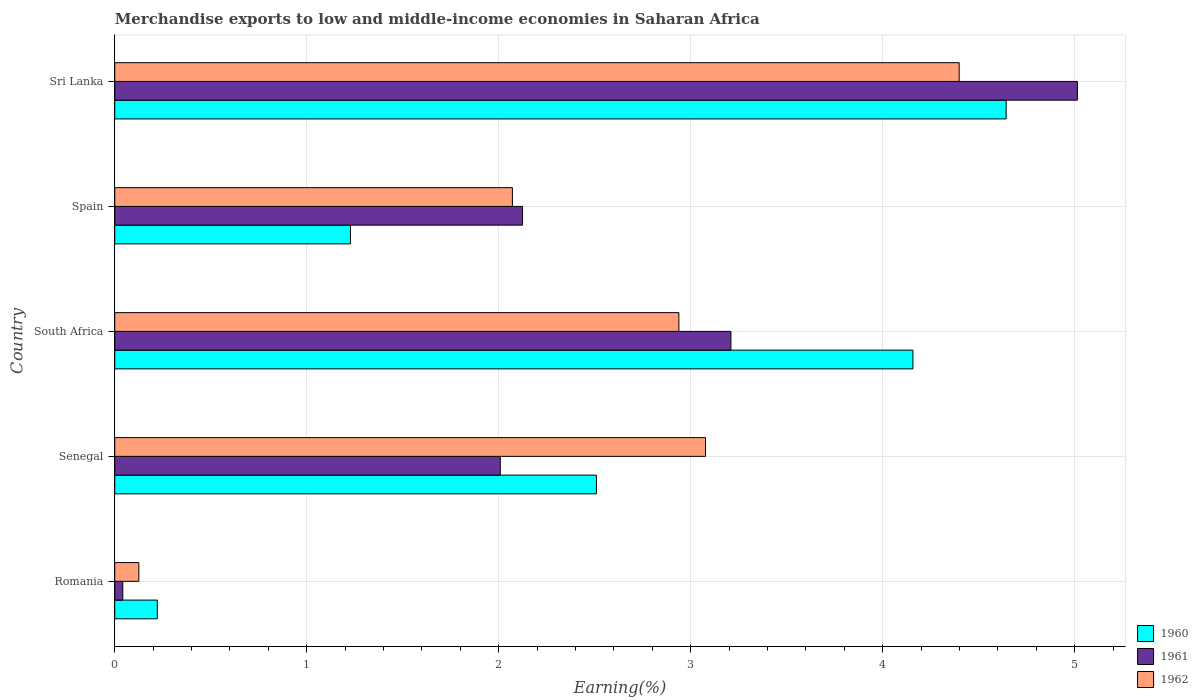How many different coloured bars are there?
Your answer should be compact. 3. How many groups of bars are there?
Make the answer very short. 5. Are the number of bars per tick equal to the number of legend labels?
Provide a short and direct response. Yes. How many bars are there on the 5th tick from the bottom?
Make the answer very short. 3. What is the label of the 3rd group of bars from the top?
Offer a very short reply. South Africa. What is the percentage of amount earned from merchandise exports in 1960 in South Africa?
Keep it short and to the point. 4.16. Across all countries, what is the maximum percentage of amount earned from merchandise exports in 1962?
Your response must be concise. 4.4. Across all countries, what is the minimum percentage of amount earned from merchandise exports in 1960?
Make the answer very short. 0.22. In which country was the percentage of amount earned from merchandise exports in 1960 maximum?
Ensure brevity in your answer.  Sri Lanka. In which country was the percentage of amount earned from merchandise exports in 1962 minimum?
Provide a succinct answer. Romania. What is the total percentage of amount earned from merchandise exports in 1962 in the graph?
Offer a very short reply. 12.61. What is the difference between the percentage of amount earned from merchandise exports in 1962 in Romania and that in Spain?
Your answer should be very brief. -1.95. What is the difference between the percentage of amount earned from merchandise exports in 1961 in Sri Lanka and the percentage of amount earned from merchandise exports in 1960 in South Africa?
Your response must be concise. 0.86. What is the average percentage of amount earned from merchandise exports in 1960 per country?
Ensure brevity in your answer.  2.55. What is the difference between the percentage of amount earned from merchandise exports in 1961 and percentage of amount earned from merchandise exports in 1962 in Romania?
Your response must be concise. -0.08. What is the ratio of the percentage of amount earned from merchandise exports in 1961 in Senegal to that in Sri Lanka?
Make the answer very short. 0.4. Is the percentage of amount earned from merchandise exports in 1962 in Senegal less than that in Sri Lanka?
Provide a short and direct response. Yes. What is the difference between the highest and the second highest percentage of amount earned from merchandise exports in 1960?
Ensure brevity in your answer.  0.49. What is the difference between the highest and the lowest percentage of amount earned from merchandise exports in 1960?
Your answer should be compact. 4.42. Is the sum of the percentage of amount earned from merchandise exports in 1961 in Romania and Sri Lanka greater than the maximum percentage of amount earned from merchandise exports in 1960 across all countries?
Make the answer very short. Yes. Is it the case that in every country, the sum of the percentage of amount earned from merchandise exports in 1961 and percentage of amount earned from merchandise exports in 1962 is greater than the percentage of amount earned from merchandise exports in 1960?
Give a very brief answer. No. How many bars are there?
Provide a succinct answer. 15. Are all the bars in the graph horizontal?
Your answer should be compact. Yes. What is the difference between two consecutive major ticks on the X-axis?
Provide a short and direct response. 1. Are the values on the major ticks of X-axis written in scientific E-notation?
Give a very brief answer. No. Does the graph contain grids?
Offer a terse response. Yes. What is the title of the graph?
Offer a very short reply. Merchandise exports to low and middle-income economies in Saharan Africa. What is the label or title of the X-axis?
Your answer should be compact. Earning(%). What is the Earning(%) in 1960 in Romania?
Offer a very short reply. 0.22. What is the Earning(%) of 1961 in Romania?
Ensure brevity in your answer.  0.04. What is the Earning(%) of 1962 in Romania?
Make the answer very short. 0.13. What is the Earning(%) in 1960 in Senegal?
Offer a terse response. 2.51. What is the Earning(%) of 1961 in Senegal?
Give a very brief answer. 2.01. What is the Earning(%) in 1962 in Senegal?
Provide a short and direct response. 3.08. What is the Earning(%) of 1960 in South Africa?
Keep it short and to the point. 4.16. What is the Earning(%) of 1961 in South Africa?
Offer a terse response. 3.21. What is the Earning(%) of 1962 in South Africa?
Provide a short and direct response. 2.94. What is the Earning(%) of 1960 in Spain?
Provide a succinct answer. 1.23. What is the Earning(%) of 1961 in Spain?
Give a very brief answer. 2.12. What is the Earning(%) in 1962 in Spain?
Keep it short and to the point. 2.07. What is the Earning(%) of 1960 in Sri Lanka?
Your answer should be very brief. 4.64. What is the Earning(%) of 1961 in Sri Lanka?
Provide a short and direct response. 5.01. What is the Earning(%) of 1962 in Sri Lanka?
Provide a short and direct response. 4.4. Across all countries, what is the maximum Earning(%) in 1960?
Keep it short and to the point. 4.64. Across all countries, what is the maximum Earning(%) in 1961?
Offer a very short reply. 5.01. Across all countries, what is the maximum Earning(%) in 1962?
Your answer should be compact. 4.4. Across all countries, what is the minimum Earning(%) in 1960?
Give a very brief answer. 0.22. Across all countries, what is the minimum Earning(%) of 1961?
Provide a succinct answer. 0.04. Across all countries, what is the minimum Earning(%) of 1962?
Make the answer very short. 0.13. What is the total Earning(%) of 1960 in the graph?
Keep it short and to the point. 12.76. What is the total Earning(%) in 1961 in the graph?
Keep it short and to the point. 12.4. What is the total Earning(%) of 1962 in the graph?
Your answer should be very brief. 12.61. What is the difference between the Earning(%) of 1960 in Romania and that in Senegal?
Provide a short and direct response. -2.29. What is the difference between the Earning(%) of 1961 in Romania and that in Senegal?
Ensure brevity in your answer.  -1.97. What is the difference between the Earning(%) of 1962 in Romania and that in Senegal?
Keep it short and to the point. -2.95. What is the difference between the Earning(%) in 1960 in Romania and that in South Africa?
Give a very brief answer. -3.94. What is the difference between the Earning(%) in 1961 in Romania and that in South Africa?
Keep it short and to the point. -3.17. What is the difference between the Earning(%) in 1962 in Romania and that in South Africa?
Your answer should be compact. -2.81. What is the difference between the Earning(%) of 1960 in Romania and that in Spain?
Give a very brief answer. -1.01. What is the difference between the Earning(%) in 1961 in Romania and that in Spain?
Make the answer very short. -2.08. What is the difference between the Earning(%) of 1962 in Romania and that in Spain?
Offer a terse response. -1.95. What is the difference between the Earning(%) of 1960 in Romania and that in Sri Lanka?
Keep it short and to the point. -4.42. What is the difference between the Earning(%) of 1961 in Romania and that in Sri Lanka?
Provide a succinct answer. -4.97. What is the difference between the Earning(%) in 1962 in Romania and that in Sri Lanka?
Ensure brevity in your answer.  -4.27. What is the difference between the Earning(%) in 1960 in Senegal and that in South Africa?
Make the answer very short. -1.65. What is the difference between the Earning(%) in 1961 in Senegal and that in South Africa?
Your response must be concise. -1.2. What is the difference between the Earning(%) in 1962 in Senegal and that in South Africa?
Provide a short and direct response. 0.14. What is the difference between the Earning(%) of 1960 in Senegal and that in Spain?
Give a very brief answer. 1.28. What is the difference between the Earning(%) in 1961 in Senegal and that in Spain?
Make the answer very short. -0.12. What is the difference between the Earning(%) in 1960 in Senegal and that in Sri Lanka?
Offer a very short reply. -2.13. What is the difference between the Earning(%) of 1961 in Senegal and that in Sri Lanka?
Offer a terse response. -3.01. What is the difference between the Earning(%) of 1962 in Senegal and that in Sri Lanka?
Give a very brief answer. -1.32. What is the difference between the Earning(%) of 1960 in South Africa and that in Spain?
Your answer should be very brief. 2.93. What is the difference between the Earning(%) of 1961 in South Africa and that in Spain?
Your response must be concise. 1.09. What is the difference between the Earning(%) in 1962 in South Africa and that in Spain?
Keep it short and to the point. 0.87. What is the difference between the Earning(%) of 1960 in South Africa and that in Sri Lanka?
Keep it short and to the point. -0.49. What is the difference between the Earning(%) of 1961 in South Africa and that in Sri Lanka?
Keep it short and to the point. -1.8. What is the difference between the Earning(%) in 1962 in South Africa and that in Sri Lanka?
Ensure brevity in your answer.  -1.46. What is the difference between the Earning(%) in 1960 in Spain and that in Sri Lanka?
Your answer should be compact. -3.42. What is the difference between the Earning(%) of 1961 in Spain and that in Sri Lanka?
Provide a succinct answer. -2.89. What is the difference between the Earning(%) in 1962 in Spain and that in Sri Lanka?
Keep it short and to the point. -2.33. What is the difference between the Earning(%) in 1960 in Romania and the Earning(%) in 1961 in Senegal?
Your answer should be compact. -1.79. What is the difference between the Earning(%) of 1960 in Romania and the Earning(%) of 1962 in Senegal?
Your answer should be compact. -2.86. What is the difference between the Earning(%) in 1961 in Romania and the Earning(%) in 1962 in Senegal?
Offer a very short reply. -3.04. What is the difference between the Earning(%) in 1960 in Romania and the Earning(%) in 1961 in South Africa?
Ensure brevity in your answer.  -2.99. What is the difference between the Earning(%) of 1960 in Romania and the Earning(%) of 1962 in South Africa?
Your answer should be very brief. -2.72. What is the difference between the Earning(%) of 1961 in Romania and the Earning(%) of 1962 in South Africa?
Give a very brief answer. -2.9. What is the difference between the Earning(%) of 1960 in Romania and the Earning(%) of 1961 in Spain?
Give a very brief answer. -1.9. What is the difference between the Earning(%) of 1960 in Romania and the Earning(%) of 1962 in Spain?
Your response must be concise. -1.85. What is the difference between the Earning(%) in 1961 in Romania and the Earning(%) in 1962 in Spain?
Provide a succinct answer. -2.03. What is the difference between the Earning(%) in 1960 in Romania and the Earning(%) in 1961 in Sri Lanka?
Offer a very short reply. -4.79. What is the difference between the Earning(%) in 1960 in Romania and the Earning(%) in 1962 in Sri Lanka?
Provide a short and direct response. -4.18. What is the difference between the Earning(%) in 1961 in Romania and the Earning(%) in 1962 in Sri Lanka?
Provide a succinct answer. -4.36. What is the difference between the Earning(%) in 1960 in Senegal and the Earning(%) in 1961 in South Africa?
Keep it short and to the point. -0.7. What is the difference between the Earning(%) of 1960 in Senegal and the Earning(%) of 1962 in South Africa?
Make the answer very short. -0.43. What is the difference between the Earning(%) in 1961 in Senegal and the Earning(%) in 1962 in South Africa?
Provide a succinct answer. -0.93. What is the difference between the Earning(%) of 1960 in Senegal and the Earning(%) of 1961 in Spain?
Provide a short and direct response. 0.38. What is the difference between the Earning(%) in 1960 in Senegal and the Earning(%) in 1962 in Spain?
Your answer should be compact. 0.44. What is the difference between the Earning(%) in 1961 in Senegal and the Earning(%) in 1962 in Spain?
Provide a succinct answer. -0.06. What is the difference between the Earning(%) in 1960 in Senegal and the Earning(%) in 1961 in Sri Lanka?
Offer a very short reply. -2.51. What is the difference between the Earning(%) of 1960 in Senegal and the Earning(%) of 1962 in Sri Lanka?
Give a very brief answer. -1.89. What is the difference between the Earning(%) in 1961 in Senegal and the Earning(%) in 1962 in Sri Lanka?
Your answer should be compact. -2.39. What is the difference between the Earning(%) in 1960 in South Africa and the Earning(%) in 1961 in Spain?
Provide a succinct answer. 2.03. What is the difference between the Earning(%) in 1960 in South Africa and the Earning(%) in 1962 in Spain?
Your answer should be compact. 2.09. What is the difference between the Earning(%) of 1961 in South Africa and the Earning(%) of 1962 in Spain?
Provide a short and direct response. 1.14. What is the difference between the Earning(%) of 1960 in South Africa and the Earning(%) of 1961 in Sri Lanka?
Your answer should be compact. -0.86. What is the difference between the Earning(%) of 1960 in South Africa and the Earning(%) of 1962 in Sri Lanka?
Your answer should be very brief. -0.24. What is the difference between the Earning(%) of 1961 in South Africa and the Earning(%) of 1962 in Sri Lanka?
Ensure brevity in your answer.  -1.19. What is the difference between the Earning(%) in 1960 in Spain and the Earning(%) in 1961 in Sri Lanka?
Make the answer very short. -3.79. What is the difference between the Earning(%) in 1960 in Spain and the Earning(%) in 1962 in Sri Lanka?
Offer a terse response. -3.17. What is the difference between the Earning(%) of 1961 in Spain and the Earning(%) of 1962 in Sri Lanka?
Give a very brief answer. -2.27. What is the average Earning(%) in 1960 per country?
Provide a succinct answer. 2.55. What is the average Earning(%) of 1961 per country?
Ensure brevity in your answer.  2.48. What is the average Earning(%) in 1962 per country?
Your answer should be very brief. 2.52. What is the difference between the Earning(%) in 1960 and Earning(%) in 1961 in Romania?
Offer a terse response. 0.18. What is the difference between the Earning(%) of 1960 and Earning(%) of 1962 in Romania?
Ensure brevity in your answer.  0.1. What is the difference between the Earning(%) in 1961 and Earning(%) in 1962 in Romania?
Make the answer very short. -0.08. What is the difference between the Earning(%) in 1960 and Earning(%) in 1961 in Senegal?
Your answer should be very brief. 0.5. What is the difference between the Earning(%) of 1960 and Earning(%) of 1962 in Senegal?
Your response must be concise. -0.57. What is the difference between the Earning(%) in 1961 and Earning(%) in 1962 in Senegal?
Your answer should be very brief. -1.07. What is the difference between the Earning(%) of 1960 and Earning(%) of 1961 in South Africa?
Offer a very short reply. 0.95. What is the difference between the Earning(%) in 1960 and Earning(%) in 1962 in South Africa?
Provide a short and direct response. 1.22. What is the difference between the Earning(%) of 1961 and Earning(%) of 1962 in South Africa?
Offer a terse response. 0.27. What is the difference between the Earning(%) of 1960 and Earning(%) of 1961 in Spain?
Give a very brief answer. -0.9. What is the difference between the Earning(%) in 1960 and Earning(%) in 1962 in Spain?
Your answer should be very brief. -0.84. What is the difference between the Earning(%) of 1961 and Earning(%) of 1962 in Spain?
Your answer should be compact. 0.05. What is the difference between the Earning(%) of 1960 and Earning(%) of 1961 in Sri Lanka?
Provide a short and direct response. -0.37. What is the difference between the Earning(%) in 1960 and Earning(%) in 1962 in Sri Lanka?
Provide a short and direct response. 0.24. What is the difference between the Earning(%) of 1961 and Earning(%) of 1962 in Sri Lanka?
Provide a succinct answer. 0.62. What is the ratio of the Earning(%) of 1960 in Romania to that in Senegal?
Provide a succinct answer. 0.09. What is the ratio of the Earning(%) of 1961 in Romania to that in Senegal?
Keep it short and to the point. 0.02. What is the ratio of the Earning(%) of 1962 in Romania to that in Senegal?
Your answer should be very brief. 0.04. What is the ratio of the Earning(%) in 1960 in Romania to that in South Africa?
Ensure brevity in your answer.  0.05. What is the ratio of the Earning(%) of 1961 in Romania to that in South Africa?
Keep it short and to the point. 0.01. What is the ratio of the Earning(%) in 1962 in Romania to that in South Africa?
Keep it short and to the point. 0.04. What is the ratio of the Earning(%) in 1960 in Romania to that in Spain?
Provide a succinct answer. 0.18. What is the ratio of the Earning(%) of 1961 in Romania to that in Spain?
Provide a short and direct response. 0.02. What is the ratio of the Earning(%) of 1962 in Romania to that in Spain?
Your response must be concise. 0.06. What is the ratio of the Earning(%) of 1960 in Romania to that in Sri Lanka?
Your answer should be compact. 0.05. What is the ratio of the Earning(%) of 1961 in Romania to that in Sri Lanka?
Your answer should be compact. 0.01. What is the ratio of the Earning(%) of 1962 in Romania to that in Sri Lanka?
Offer a very short reply. 0.03. What is the ratio of the Earning(%) in 1960 in Senegal to that in South Africa?
Make the answer very short. 0.6. What is the ratio of the Earning(%) in 1961 in Senegal to that in South Africa?
Your answer should be compact. 0.63. What is the ratio of the Earning(%) of 1962 in Senegal to that in South Africa?
Your answer should be very brief. 1.05. What is the ratio of the Earning(%) of 1960 in Senegal to that in Spain?
Keep it short and to the point. 2.04. What is the ratio of the Earning(%) of 1961 in Senegal to that in Spain?
Your response must be concise. 0.95. What is the ratio of the Earning(%) in 1962 in Senegal to that in Spain?
Ensure brevity in your answer.  1.49. What is the ratio of the Earning(%) in 1960 in Senegal to that in Sri Lanka?
Make the answer very short. 0.54. What is the ratio of the Earning(%) of 1961 in Senegal to that in Sri Lanka?
Give a very brief answer. 0.4. What is the ratio of the Earning(%) in 1962 in Senegal to that in Sri Lanka?
Give a very brief answer. 0.7. What is the ratio of the Earning(%) of 1960 in South Africa to that in Spain?
Offer a very short reply. 3.39. What is the ratio of the Earning(%) of 1961 in South Africa to that in Spain?
Offer a terse response. 1.51. What is the ratio of the Earning(%) in 1962 in South Africa to that in Spain?
Provide a succinct answer. 1.42. What is the ratio of the Earning(%) in 1960 in South Africa to that in Sri Lanka?
Your answer should be very brief. 0.9. What is the ratio of the Earning(%) in 1961 in South Africa to that in Sri Lanka?
Make the answer very short. 0.64. What is the ratio of the Earning(%) in 1962 in South Africa to that in Sri Lanka?
Make the answer very short. 0.67. What is the ratio of the Earning(%) in 1960 in Spain to that in Sri Lanka?
Offer a terse response. 0.26. What is the ratio of the Earning(%) in 1961 in Spain to that in Sri Lanka?
Your answer should be very brief. 0.42. What is the ratio of the Earning(%) of 1962 in Spain to that in Sri Lanka?
Give a very brief answer. 0.47. What is the difference between the highest and the second highest Earning(%) of 1960?
Your response must be concise. 0.49. What is the difference between the highest and the second highest Earning(%) in 1961?
Offer a very short reply. 1.8. What is the difference between the highest and the second highest Earning(%) in 1962?
Ensure brevity in your answer.  1.32. What is the difference between the highest and the lowest Earning(%) in 1960?
Your answer should be very brief. 4.42. What is the difference between the highest and the lowest Earning(%) of 1961?
Your answer should be very brief. 4.97. What is the difference between the highest and the lowest Earning(%) of 1962?
Offer a very short reply. 4.27. 